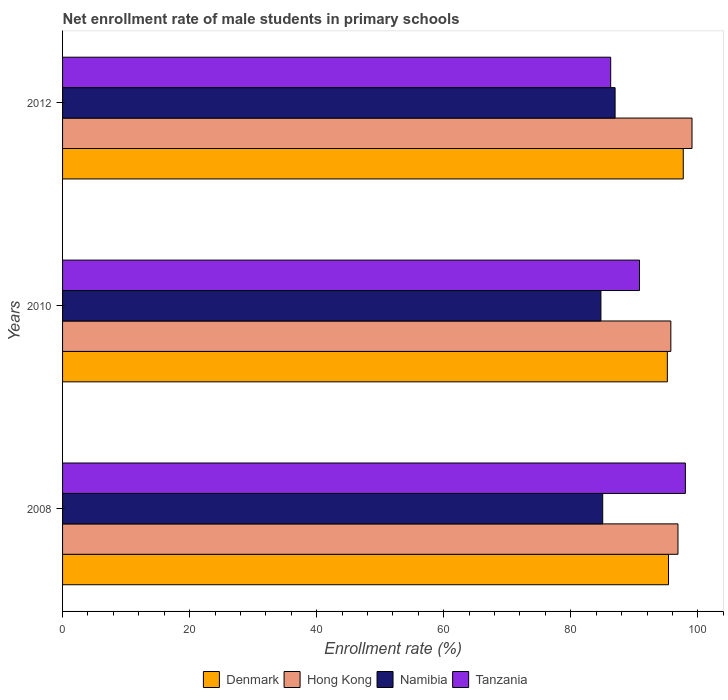How many different coloured bars are there?
Keep it short and to the point. 4. How many groups of bars are there?
Your response must be concise. 3. Are the number of bars per tick equal to the number of legend labels?
Your answer should be very brief. Yes. How many bars are there on the 3rd tick from the bottom?
Make the answer very short. 4. What is the label of the 3rd group of bars from the top?
Provide a succinct answer. 2008. What is the net enrollment rate of male students in primary schools in Tanzania in 2008?
Provide a short and direct response. 98.03. Across all years, what is the maximum net enrollment rate of male students in primary schools in Hong Kong?
Provide a short and direct response. 99.08. Across all years, what is the minimum net enrollment rate of male students in primary schools in Namibia?
Give a very brief answer. 84.74. In which year was the net enrollment rate of male students in primary schools in Tanzania maximum?
Offer a terse response. 2008. What is the total net enrollment rate of male students in primary schools in Hong Kong in the graph?
Your response must be concise. 291.7. What is the difference between the net enrollment rate of male students in primary schools in Namibia in 2008 and that in 2012?
Offer a very short reply. -1.95. What is the difference between the net enrollment rate of male students in primary schools in Namibia in 2008 and the net enrollment rate of male students in primary schools in Denmark in 2012?
Your answer should be very brief. -12.68. What is the average net enrollment rate of male students in primary schools in Namibia per year?
Ensure brevity in your answer.  85.58. In the year 2008, what is the difference between the net enrollment rate of male students in primary schools in Namibia and net enrollment rate of male students in primary schools in Denmark?
Offer a terse response. -10.36. In how many years, is the net enrollment rate of male students in primary schools in Namibia greater than 20 %?
Give a very brief answer. 3. What is the ratio of the net enrollment rate of male students in primary schools in Namibia in 2008 to that in 2010?
Offer a terse response. 1. Is the net enrollment rate of male students in primary schools in Tanzania in 2008 less than that in 2012?
Your response must be concise. No. What is the difference between the highest and the second highest net enrollment rate of male students in primary schools in Denmark?
Your answer should be compact. 2.32. What is the difference between the highest and the lowest net enrollment rate of male students in primary schools in Tanzania?
Your response must be concise. 11.76. In how many years, is the net enrollment rate of male students in primary schools in Namibia greater than the average net enrollment rate of male students in primary schools in Namibia taken over all years?
Your answer should be compact. 1. Is the sum of the net enrollment rate of male students in primary schools in Namibia in 2008 and 2012 greater than the maximum net enrollment rate of male students in primary schools in Tanzania across all years?
Keep it short and to the point. Yes. What does the 2nd bar from the top in 2010 represents?
Keep it short and to the point. Namibia. What does the 2nd bar from the bottom in 2008 represents?
Ensure brevity in your answer.  Hong Kong. Is it the case that in every year, the sum of the net enrollment rate of male students in primary schools in Namibia and net enrollment rate of male students in primary schools in Tanzania is greater than the net enrollment rate of male students in primary schools in Hong Kong?
Ensure brevity in your answer.  Yes. How many years are there in the graph?
Keep it short and to the point. 3. Are the values on the major ticks of X-axis written in scientific E-notation?
Provide a succinct answer. No. Does the graph contain any zero values?
Provide a short and direct response. No. Does the graph contain grids?
Give a very brief answer. No. How are the legend labels stacked?
Your answer should be very brief. Horizontal. What is the title of the graph?
Give a very brief answer. Net enrollment rate of male students in primary schools. Does "Ukraine" appear as one of the legend labels in the graph?
Offer a very short reply. No. What is the label or title of the X-axis?
Give a very brief answer. Enrollment rate (%). What is the Enrollment rate (%) in Denmark in 2008?
Provide a succinct answer. 95.38. What is the Enrollment rate (%) in Hong Kong in 2008?
Offer a terse response. 96.87. What is the Enrollment rate (%) of Namibia in 2008?
Ensure brevity in your answer.  85.02. What is the Enrollment rate (%) in Tanzania in 2008?
Provide a short and direct response. 98.03. What is the Enrollment rate (%) in Denmark in 2010?
Your response must be concise. 95.2. What is the Enrollment rate (%) of Hong Kong in 2010?
Your response must be concise. 95.75. What is the Enrollment rate (%) in Namibia in 2010?
Make the answer very short. 84.74. What is the Enrollment rate (%) in Tanzania in 2010?
Keep it short and to the point. 90.81. What is the Enrollment rate (%) in Denmark in 2012?
Your response must be concise. 97.7. What is the Enrollment rate (%) of Hong Kong in 2012?
Offer a very short reply. 99.08. What is the Enrollment rate (%) of Namibia in 2012?
Keep it short and to the point. 86.97. What is the Enrollment rate (%) of Tanzania in 2012?
Keep it short and to the point. 86.28. Across all years, what is the maximum Enrollment rate (%) in Denmark?
Give a very brief answer. 97.7. Across all years, what is the maximum Enrollment rate (%) in Hong Kong?
Your answer should be compact. 99.08. Across all years, what is the maximum Enrollment rate (%) of Namibia?
Offer a very short reply. 86.97. Across all years, what is the maximum Enrollment rate (%) of Tanzania?
Keep it short and to the point. 98.03. Across all years, what is the minimum Enrollment rate (%) of Denmark?
Give a very brief answer. 95.2. Across all years, what is the minimum Enrollment rate (%) in Hong Kong?
Your answer should be compact. 95.75. Across all years, what is the minimum Enrollment rate (%) of Namibia?
Give a very brief answer. 84.74. Across all years, what is the minimum Enrollment rate (%) of Tanzania?
Your answer should be very brief. 86.28. What is the total Enrollment rate (%) in Denmark in the graph?
Your answer should be very brief. 288.28. What is the total Enrollment rate (%) of Hong Kong in the graph?
Make the answer very short. 291.7. What is the total Enrollment rate (%) in Namibia in the graph?
Provide a short and direct response. 256.74. What is the total Enrollment rate (%) of Tanzania in the graph?
Keep it short and to the point. 275.13. What is the difference between the Enrollment rate (%) in Denmark in 2008 and that in 2010?
Provide a short and direct response. 0.18. What is the difference between the Enrollment rate (%) in Hong Kong in 2008 and that in 2010?
Ensure brevity in your answer.  1.12. What is the difference between the Enrollment rate (%) in Namibia in 2008 and that in 2010?
Give a very brief answer. 0.28. What is the difference between the Enrollment rate (%) of Tanzania in 2008 and that in 2010?
Keep it short and to the point. 7.22. What is the difference between the Enrollment rate (%) of Denmark in 2008 and that in 2012?
Your answer should be very brief. -2.32. What is the difference between the Enrollment rate (%) of Hong Kong in 2008 and that in 2012?
Keep it short and to the point. -2.21. What is the difference between the Enrollment rate (%) of Namibia in 2008 and that in 2012?
Ensure brevity in your answer.  -1.95. What is the difference between the Enrollment rate (%) in Tanzania in 2008 and that in 2012?
Make the answer very short. 11.76. What is the difference between the Enrollment rate (%) in Denmark in 2010 and that in 2012?
Your answer should be compact. -2.51. What is the difference between the Enrollment rate (%) of Hong Kong in 2010 and that in 2012?
Offer a terse response. -3.33. What is the difference between the Enrollment rate (%) in Namibia in 2010 and that in 2012?
Make the answer very short. -2.23. What is the difference between the Enrollment rate (%) of Tanzania in 2010 and that in 2012?
Provide a short and direct response. 4.54. What is the difference between the Enrollment rate (%) in Denmark in 2008 and the Enrollment rate (%) in Hong Kong in 2010?
Offer a terse response. -0.37. What is the difference between the Enrollment rate (%) of Denmark in 2008 and the Enrollment rate (%) of Namibia in 2010?
Give a very brief answer. 10.64. What is the difference between the Enrollment rate (%) of Denmark in 2008 and the Enrollment rate (%) of Tanzania in 2010?
Your answer should be compact. 4.57. What is the difference between the Enrollment rate (%) of Hong Kong in 2008 and the Enrollment rate (%) of Namibia in 2010?
Your response must be concise. 12.13. What is the difference between the Enrollment rate (%) in Hong Kong in 2008 and the Enrollment rate (%) in Tanzania in 2010?
Provide a succinct answer. 6.06. What is the difference between the Enrollment rate (%) in Namibia in 2008 and the Enrollment rate (%) in Tanzania in 2010?
Give a very brief answer. -5.79. What is the difference between the Enrollment rate (%) in Denmark in 2008 and the Enrollment rate (%) in Hong Kong in 2012?
Offer a terse response. -3.7. What is the difference between the Enrollment rate (%) of Denmark in 2008 and the Enrollment rate (%) of Namibia in 2012?
Give a very brief answer. 8.41. What is the difference between the Enrollment rate (%) in Denmark in 2008 and the Enrollment rate (%) in Tanzania in 2012?
Keep it short and to the point. 9.1. What is the difference between the Enrollment rate (%) in Hong Kong in 2008 and the Enrollment rate (%) in Namibia in 2012?
Make the answer very short. 9.9. What is the difference between the Enrollment rate (%) in Hong Kong in 2008 and the Enrollment rate (%) in Tanzania in 2012?
Give a very brief answer. 10.59. What is the difference between the Enrollment rate (%) in Namibia in 2008 and the Enrollment rate (%) in Tanzania in 2012?
Provide a succinct answer. -1.25. What is the difference between the Enrollment rate (%) of Denmark in 2010 and the Enrollment rate (%) of Hong Kong in 2012?
Make the answer very short. -3.88. What is the difference between the Enrollment rate (%) of Denmark in 2010 and the Enrollment rate (%) of Namibia in 2012?
Keep it short and to the point. 8.23. What is the difference between the Enrollment rate (%) of Denmark in 2010 and the Enrollment rate (%) of Tanzania in 2012?
Make the answer very short. 8.92. What is the difference between the Enrollment rate (%) in Hong Kong in 2010 and the Enrollment rate (%) in Namibia in 2012?
Provide a succinct answer. 8.78. What is the difference between the Enrollment rate (%) of Hong Kong in 2010 and the Enrollment rate (%) of Tanzania in 2012?
Give a very brief answer. 9.47. What is the difference between the Enrollment rate (%) of Namibia in 2010 and the Enrollment rate (%) of Tanzania in 2012?
Make the answer very short. -1.54. What is the average Enrollment rate (%) in Denmark per year?
Keep it short and to the point. 96.09. What is the average Enrollment rate (%) of Hong Kong per year?
Ensure brevity in your answer.  97.23. What is the average Enrollment rate (%) in Namibia per year?
Make the answer very short. 85.58. What is the average Enrollment rate (%) in Tanzania per year?
Your answer should be compact. 91.71. In the year 2008, what is the difference between the Enrollment rate (%) of Denmark and Enrollment rate (%) of Hong Kong?
Your answer should be compact. -1.49. In the year 2008, what is the difference between the Enrollment rate (%) in Denmark and Enrollment rate (%) in Namibia?
Provide a short and direct response. 10.36. In the year 2008, what is the difference between the Enrollment rate (%) of Denmark and Enrollment rate (%) of Tanzania?
Your answer should be compact. -2.65. In the year 2008, what is the difference between the Enrollment rate (%) of Hong Kong and Enrollment rate (%) of Namibia?
Your response must be concise. 11.85. In the year 2008, what is the difference between the Enrollment rate (%) in Hong Kong and Enrollment rate (%) in Tanzania?
Offer a terse response. -1.17. In the year 2008, what is the difference between the Enrollment rate (%) in Namibia and Enrollment rate (%) in Tanzania?
Your answer should be compact. -13.01. In the year 2010, what is the difference between the Enrollment rate (%) in Denmark and Enrollment rate (%) in Hong Kong?
Keep it short and to the point. -0.55. In the year 2010, what is the difference between the Enrollment rate (%) of Denmark and Enrollment rate (%) of Namibia?
Offer a terse response. 10.46. In the year 2010, what is the difference between the Enrollment rate (%) in Denmark and Enrollment rate (%) in Tanzania?
Offer a very short reply. 4.38. In the year 2010, what is the difference between the Enrollment rate (%) of Hong Kong and Enrollment rate (%) of Namibia?
Your answer should be very brief. 11.01. In the year 2010, what is the difference between the Enrollment rate (%) of Hong Kong and Enrollment rate (%) of Tanzania?
Your answer should be compact. 4.93. In the year 2010, what is the difference between the Enrollment rate (%) of Namibia and Enrollment rate (%) of Tanzania?
Keep it short and to the point. -6.07. In the year 2012, what is the difference between the Enrollment rate (%) of Denmark and Enrollment rate (%) of Hong Kong?
Offer a terse response. -1.38. In the year 2012, what is the difference between the Enrollment rate (%) of Denmark and Enrollment rate (%) of Namibia?
Offer a very short reply. 10.73. In the year 2012, what is the difference between the Enrollment rate (%) in Denmark and Enrollment rate (%) in Tanzania?
Your answer should be compact. 11.43. In the year 2012, what is the difference between the Enrollment rate (%) of Hong Kong and Enrollment rate (%) of Namibia?
Keep it short and to the point. 12.11. In the year 2012, what is the difference between the Enrollment rate (%) of Hong Kong and Enrollment rate (%) of Tanzania?
Your answer should be very brief. 12.8. In the year 2012, what is the difference between the Enrollment rate (%) in Namibia and Enrollment rate (%) in Tanzania?
Your answer should be compact. 0.69. What is the ratio of the Enrollment rate (%) in Denmark in 2008 to that in 2010?
Keep it short and to the point. 1. What is the ratio of the Enrollment rate (%) of Hong Kong in 2008 to that in 2010?
Provide a succinct answer. 1.01. What is the ratio of the Enrollment rate (%) of Tanzania in 2008 to that in 2010?
Make the answer very short. 1.08. What is the ratio of the Enrollment rate (%) in Denmark in 2008 to that in 2012?
Give a very brief answer. 0.98. What is the ratio of the Enrollment rate (%) in Hong Kong in 2008 to that in 2012?
Your response must be concise. 0.98. What is the ratio of the Enrollment rate (%) in Namibia in 2008 to that in 2012?
Make the answer very short. 0.98. What is the ratio of the Enrollment rate (%) in Tanzania in 2008 to that in 2012?
Give a very brief answer. 1.14. What is the ratio of the Enrollment rate (%) in Denmark in 2010 to that in 2012?
Ensure brevity in your answer.  0.97. What is the ratio of the Enrollment rate (%) of Hong Kong in 2010 to that in 2012?
Make the answer very short. 0.97. What is the ratio of the Enrollment rate (%) in Namibia in 2010 to that in 2012?
Offer a very short reply. 0.97. What is the ratio of the Enrollment rate (%) in Tanzania in 2010 to that in 2012?
Provide a short and direct response. 1.05. What is the difference between the highest and the second highest Enrollment rate (%) of Denmark?
Offer a terse response. 2.32. What is the difference between the highest and the second highest Enrollment rate (%) in Hong Kong?
Make the answer very short. 2.21. What is the difference between the highest and the second highest Enrollment rate (%) of Namibia?
Offer a terse response. 1.95. What is the difference between the highest and the second highest Enrollment rate (%) in Tanzania?
Ensure brevity in your answer.  7.22. What is the difference between the highest and the lowest Enrollment rate (%) in Denmark?
Provide a short and direct response. 2.51. What is the difference between the highest and the lowest Enrollment rate (%) in Hong Kong?
Offer a very short reply. 3.33. What is the difference between the highest and the lowest Enrollment rate (%) of Namibia?
Provide a short and direct response. 2.23. What is the difference between the highest and the lowest Enrollment rate (%) in Tanzania?
Provide a short and direct response. 11.76. 